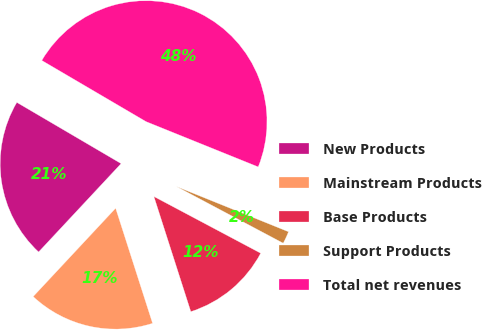<chart> <loc_0><loc_0><loc_500><loc_500><pie_chart><fcel>New Products<fcel>Mainstream Products<fcel>Base Products<fcel>Support Products<fcel>Total net revenues<nl><fcel>21.49%<fcel>16.89%<fcel>12.29%<fcel>1.66%<fcel>47.66%<nl></chart> 